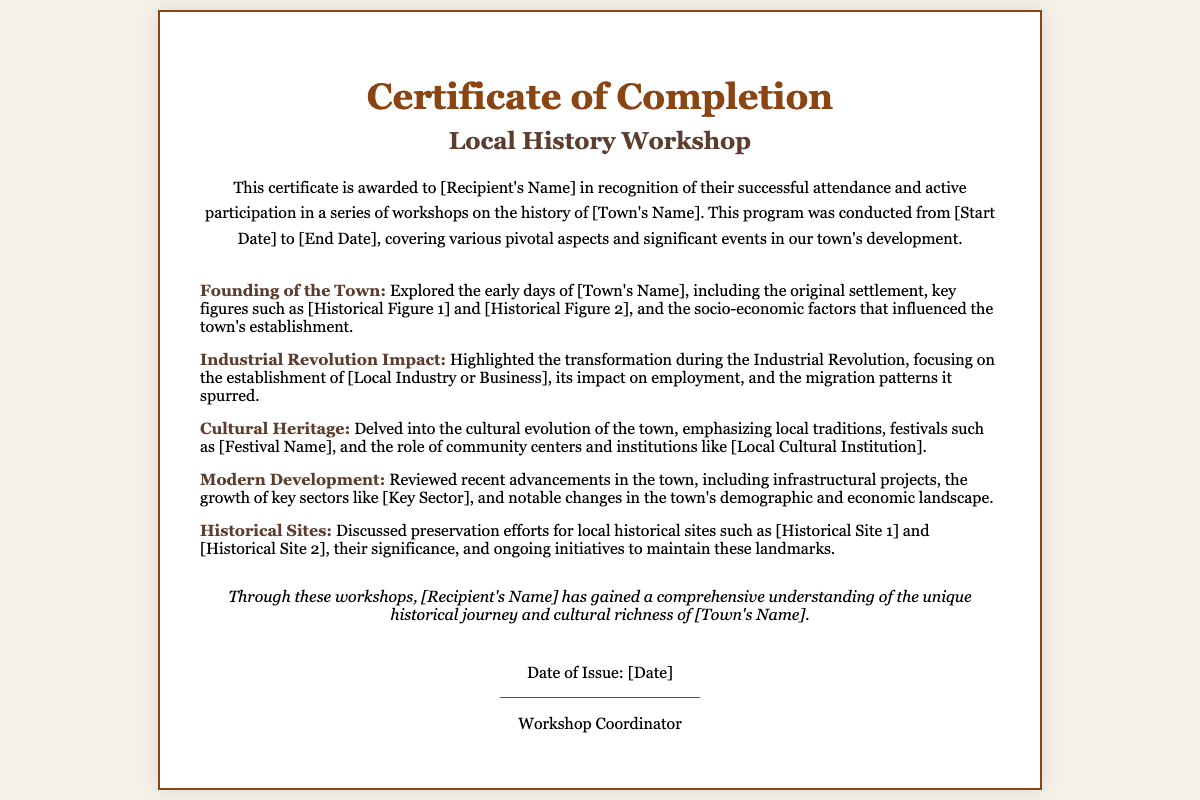What is the title of the workshop? The title of the workshop is stated at the top of the certificate.
Answer: Local History Workshop Who is the certificate awarded to? The recipient's name is noted in the body of the certificate.
Answer: [Recipient's Name] What is the start date of the workshops? The start date is indicated in the recognition section of the certificate.
Answer: [Start Date] What major event did the workshops cover related to the town's development? This refers to a significant topic discussed during the workshops.
Answer: Founding of the Town What cultural event was highlighted in the workshop? This is a specific festival discussed in the cultural heritage section of the certificate.
Answer: [Festival Name] Which industry was mentioned in the context of the Industrial Revolution? This refers to the local industry or business discussed during the workshop.
Answer: [Local Industry or Business] What is one of the historical sites discussed in the workshops? This refers to a significant location included in the preservation efforts section.
Answer: [Historical Site 1] Who issued the certificate? This refers to the individual or role responsible for the certificate’s issuance.
Answer: Workshop Coordinator When was the certificate issued? The issue date is included in the signature section of the certificate.
Answer: [Date] 